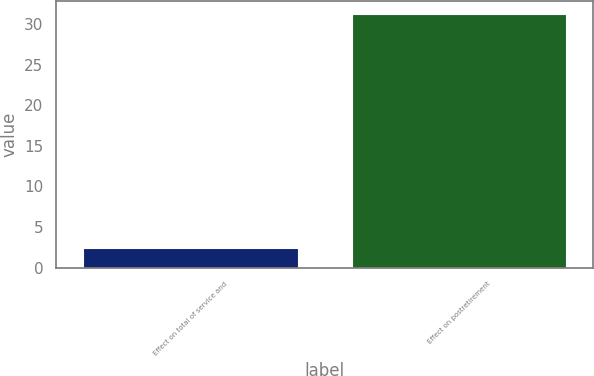Convert chart. <chart><loc_0><loc_0><loc_500><loc_500><bar_chart><fcel>Effect on total of service and<fcel>Effect on postretirement<nl><fcel>2.4<fcel>31.3<nl></chart> 